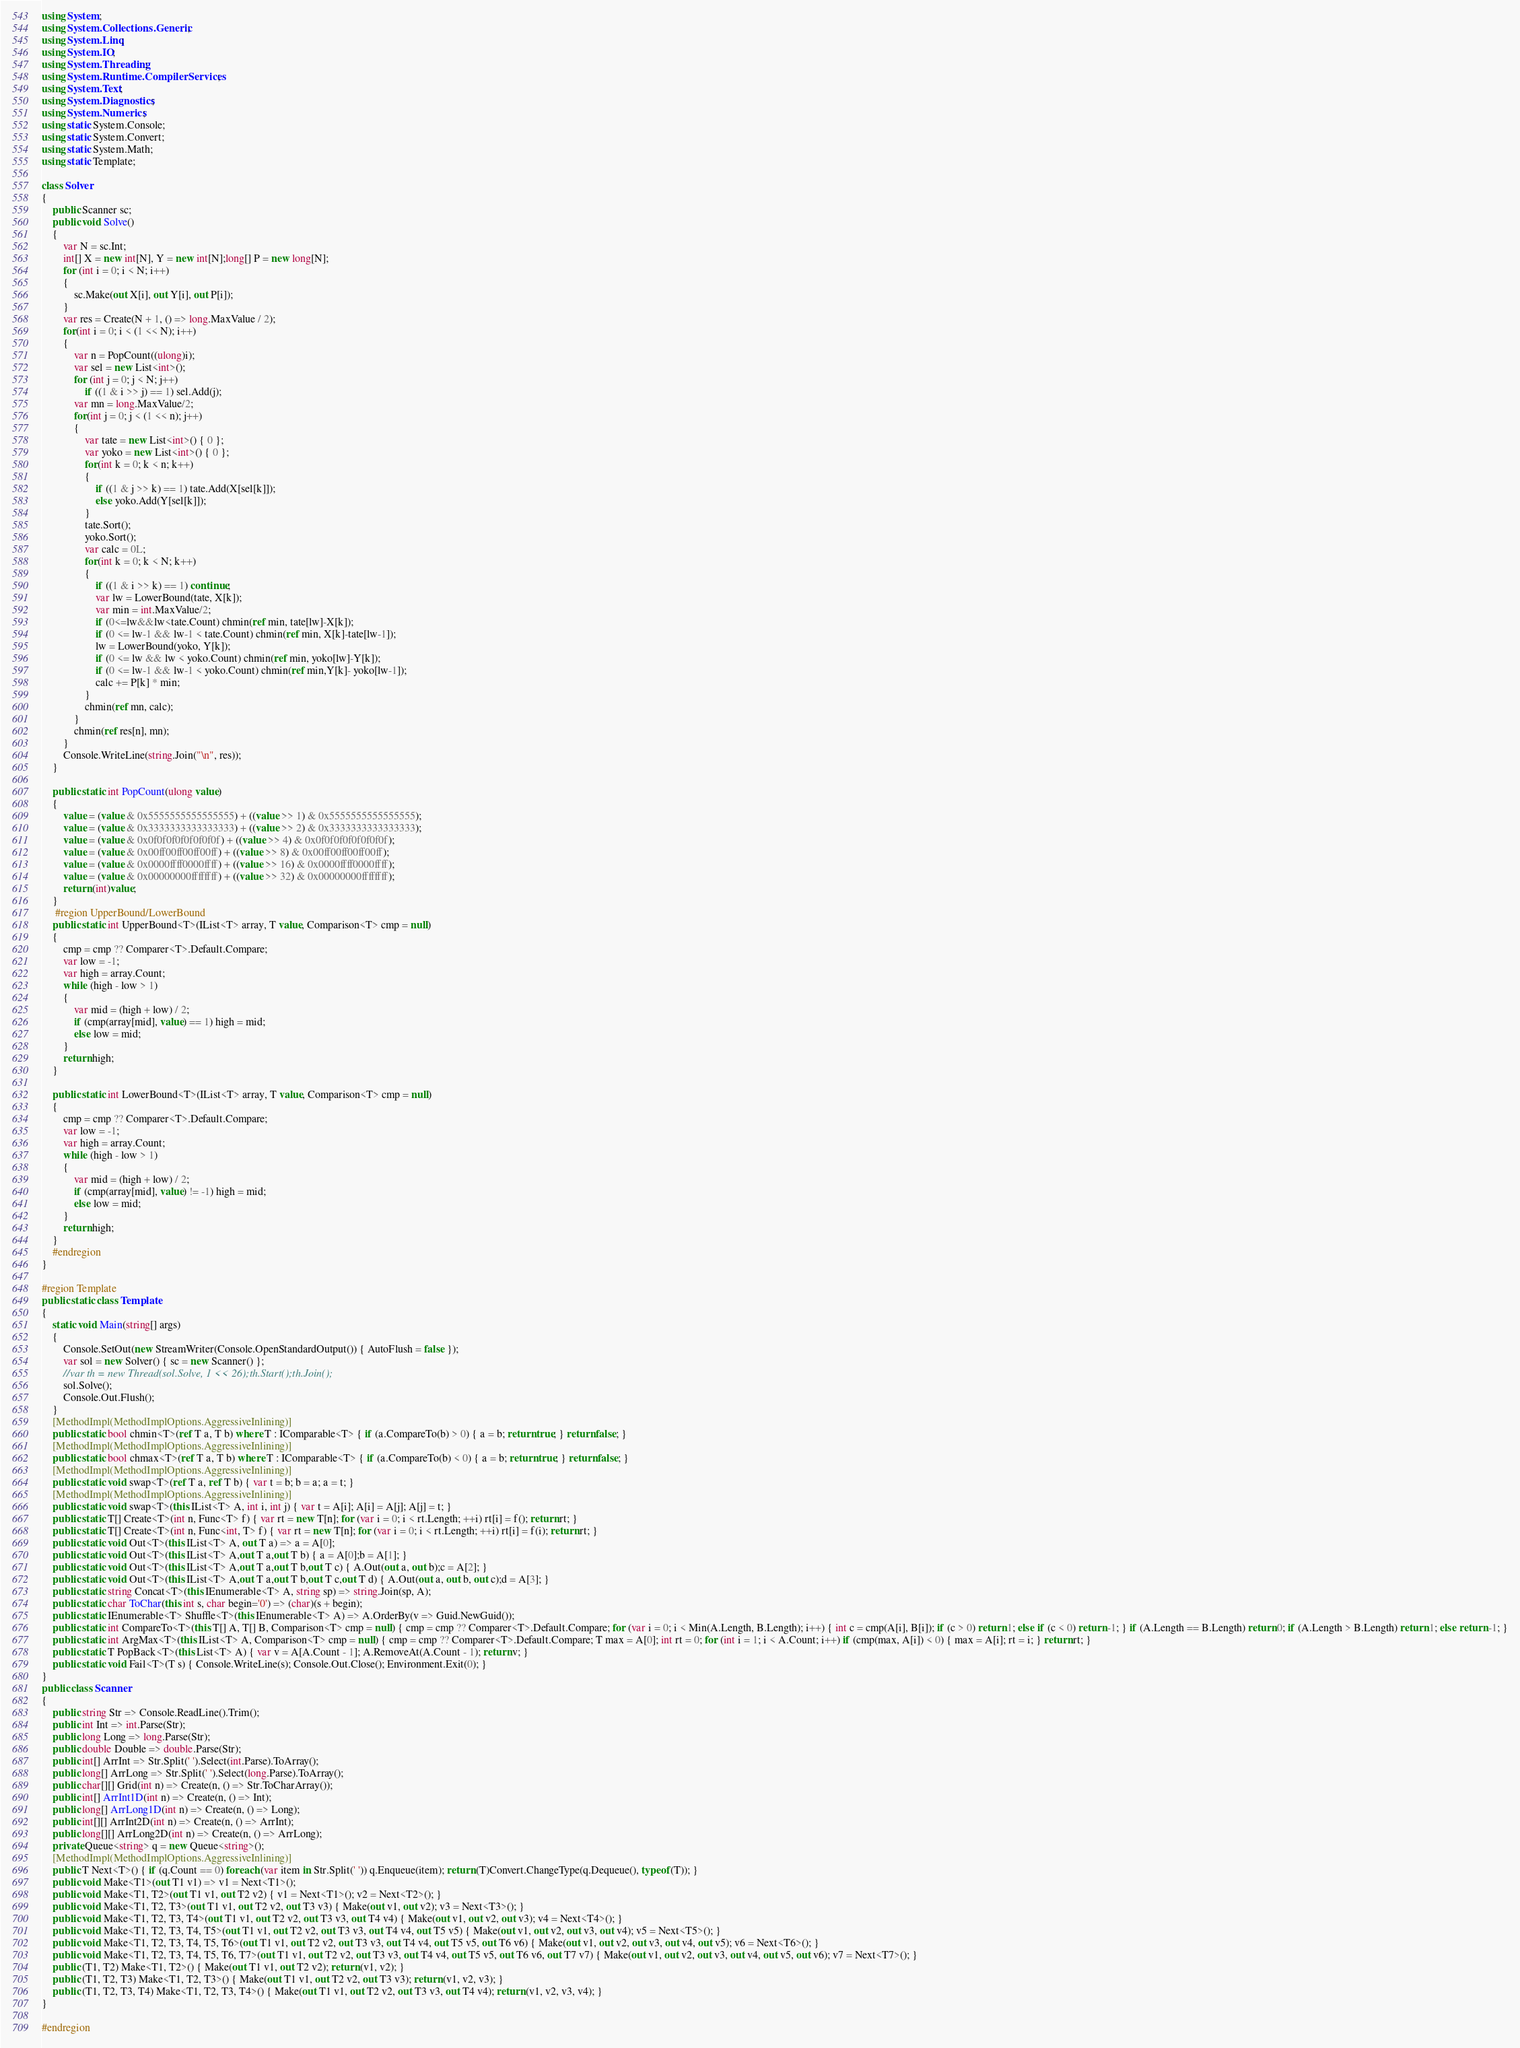<code> <loc_0><loc_0><loc_500><loc_500><_C#_>using System;
using System.Collections.Generic;
using System.Linq;
using System.IO;
using System.Threading;
using System.Runtime.CompilerServices;
using System.Text;
using System.Diagnostics;
using System.Numerics;
using static System.Console;
using static System.Convert;
using static System.Math;
using static Template;

class Solver
{
    public Scanner sc;
    public void Solve()
    {
        var N = sc.Int;
        int[] X = new int[N], Y = new int[N];long[] P = new long[N];
        for (int i = 0; i < N; i++)
        {
            sc.Make(out X[i], out Y[i], out P[i]);
        }
        var res = Create(N + 1, () => long.MaxValue / 2);
        for(int i = 0; i < (1 << N); i++)
        {
            var n = PopCount((ulong)i);
            var sel = new List<int>();
            for (int j = 0; j < N; j++)
                if ((1 & i >> j) == 1) sel.Add(j);
            var mn = long.MaxValue/2;
            for(int j = 0; j < (1 << n); j++)
            {
                var tate = new List<int>() { 0 };
                var yoko = new List<int>() { 0 };
                for(int k = 0; k < n; k++)
                {
                    if ((1 & j >> k) == 1) tate.Add(X[sel[k]]);
                    else yoko.Add(Y[sel[k]]);
                }
                tate.Sort();
                yoko.Sort();
                var calc = 0L;
                for(int k = 0; k < N; k++)
                {
                    if ((1 & i >> k) == 1) continue;
                    var lw = LowerBound(tate, X[k]);
                    var min = int.MaxValue/2;
                    if (0<=lw&&lw<tate.Count) chmin(ref min, tate[lw]-X[k]);
                    if (0 <= lw-1 && lw-1 < tate.Count) chmin(ref min, X[k]-tate[lw-1]);
                    lw = LowerBound(yoko, Y[k]);
                    if (0 <= lw && lw < yoko.Count) chmin(ref min, yoko[lw]-Y[k]);
                    if (0 <= lw-1 && lw-1 < yoko.Count) chmin(ref min,Y[k]- yoko[lw-1]);
                    calc += P[k] * min;
                }
                chmin(ref mn, calc);
            }
            chmin(ref res[n], mn);
        }
        Console.WriteLine(string.Join("\n", res));
    }

    public static int PopCount(ulong value)
    {
        value = (value & 0x5555555555555555) + ((value >> 1) & 0x5555555555555555);
        value = (value & 0x3333333333333333) + ((value >> 2) & 0x3333333333333333);
        value = (value & 0x0f0f0f0f0f0f0f0f) + ((value >> 4) & 0x0f0f0f0f0f0f0f0f);
        value = (value & 0x00ff00ff00ff00ff) + ((value >> 8) & 0x00ff00ff00ff00ff);
        value = (value & 0x0000ffff0000ffff) + ((value >> 16) & 0x0000ffff0000ffff);
        value = (value & 0x00000000ffffffff) + ((value >> 32) & 0x00000000ffffffff);
        return (int)value;
    }
     #region UpperBound/LowerBound
    public static int UpperBound<T>(IList<T> array, T value, Comparison<T> cmp = null)
    {
        cmp = cmp ?? Comparer<T>.Default.Compare;
        var low = -1;
        var high = array.Count;
        while (high - low > 1)
        {
            var mid = (high + low) / 2;
            if (cmp(array[mid], value) == 1) high = mid;
            else low = mid;
        }
        return high;
    }

    public static int LowerBound<T>(IList<T> array, T value, Comparison<T> cmp = null)
    {
        cmp = cmp ?? Comparer<T>.Default.Compare;
        var low = -1;
        var high = array.Count;
        while (high - low > 1)
        {
            var mid = (high + low) / 2;
            if (cmp(array[mid], value) != -1) high = mid;
            else low = mid;
        }
        return high;
    }
    #endregion
}

#region Template
public static class Template
{
    static void Main(string[] args)
    {
        Console.SetOut(new StreamWriter(Console.OpenStandardOutput()) { AutoFlush = false });
        var sol = new Solver() { sc = new Scanner() };
        //var th = new Thread(sol.Solve, 1 << 26);th.Start();th.Join();
        sol.Solve();
        Console.Out.Flush();
    }
    [MethodImpl(MethodImplOptions.AggressiveInlining)]
    public static bool chmin<T>(ref T a, T b) where T : IComparable<T> { if (a.CompareTo(b) > 0) { a = b; return true; } return false; }
    [MethodImpl(MethodImplOptions.AggressiveInlining)]
    public static bool chmax<T>(ref T a, T b) where T : IComparable<T> { if (a.CompareTo(b) < 0) { a = b; return true; } return false; }
    [MethodImpl(MethodImplOptions.AggressiveInlining)]
    public static void swap<T>(ref T a, ref T b) { var t = b; b = a; a = t; }
    [MethodImpl(MethodImplOptions.AggressiveInlining)]
    public static void swap<T>(this IList<T> A, int i, int j) { var t = A[i]; A[i] = A[j]; A[j] = t; }
    public static T[] Create<T>(int n, Func<T> f) { var rt = new T[n]; for (var i = 0; i < rt.Length; ++i) rt[i] = f(); return rt; }
    public static T[] Create<T>(int n, Func<int, T> f) { var rt = new T[n]; for (var i = 0; i < rt.Length; ++i) rt[i] = f(i); return rt; }
    public static void Out<T>(this IList<T> A, out T a) => a = A[0];
    public static void Out<T>(this IList<T> A,out T a,out T b) { a = A[0];b = A[1]; }
    public static void Out<T>(this IList<T> A,out T a,out T b,out T c) { A.Out(out a, out b);c = A[2]; }
    public static void Out<T>(this IList<T> A,out T a,out T b,out T c,out T d) { A.Out(out a, out b, out c);d = A[3]; }
    public static string Concat<T>(this IEnumerable<T> A, string sp) => string.Join(sp, A);
    public static char ToChar(this int s, char begin='0') => (char)(s + begin);
    public static IEnumerable<T> Shuffle<T>(this IEnumerable<T> A) => A.OrderBy(v => Guid.NewGuid());
    public static int CompareTo<T>(this T[] A, T[] B, Comparison<T> cmp = null) { cmp = cmp ?? Comparer<T>.Default.Compare; for (var i = 0; i < Min(A.Length, B.Length); i++) { int c = cmp(A[i], B[i]); if (c > 0) return 1; else if (c < 0) return -1; } if (A.Length == B.Length) return 0; if (A.Length > B.Length) return 1; else return -1; }
    public static int ArgMax<T>(this IList<T> A, Comparison<T> cmp = null) { cmp = cmp ?? Comparer<T>.Default.Compare; T max = A[0]; int rt = 0; for (int i = 1; i < A.Count; i++) if (cmp(max, A[i]) < 0) { max = A[i]; rt = i; } return rt; }
    public static T PopBack<T>(this List<T> A) { var v = A[A.Count - 1]; A.RemoveAt(A.Count - 1); return v; }
    public static void Fail<T>(T s) { Console.WriteLine(s); Console.Out.Close(); Environment.Exit(0); }
}
public class Scanner
{
    public string Str => Console.ReadLine().Trim();
    public int Int => int.Parse(Str);
    public long Long => long.Parse(Str);
    public double Double => double.Parse(Str);
    public int[] ArrInt => Str.Split(' ').Select(int.Parse).ToArray();
    public long[] ArrLong => Str.Split(' ').Select(long.Parse).ToArray();
    public char[][] Grid(int n) => Create(n, () => Str.ToCharArray());
    public int[] ArrInt1D(int n) => Create(n, () => Int);
    public long[] ArrLong1D(int n) => Create(n, () => Long);
    public int[][] ArrInt2D(int n) => Create(n, () => ArrInt);
    public long[][] ArrLong2D(int n) => Create(n, () => ArrLong);
    private Queue<string> q = new Queue<string>();
    [MethodImpl(MethodImplOptions.AggressiveInlining)]
    public T Next<T>() { if (q.Count == 0) foreach (var item in Str.Split(' ')) q.Enqueue(item); return (T)Convert.ChangeType(q.Dequeue(), typeof(T)); }
    public void Make<T1>(out T1 v1) => v1 = Next<T1>();
    public void Make<T1, T2>(out T1 v1, out T2 v2) { v1 = Next<T1>(); v2 = Next<T2>(); }
    public void Make<T1, T2, T3>(out T1 v1, out T2 v2, out T3 v3) { Make(out v1, out v2); v3 = Next<T3>(); }
    public void Make<T1, T2, T3, T4>(out T1 v1, out T2 v2, out T3 v3, out T4 v4) { Make(out v1, out v2, out v3); v4 = Next<T4>(); }
    public void Make<T1, T2, T3, T4, T5>(out T1 v1, out T2 v2, out T3 v3, out T4 v4, out T5 v5) { Make(out v1, out v2, out v3, out v4); v5 = Next<T5>(); }
    public void Make<T1, T2, T3, T4, T5, T6>(out T1 v1, out T2 v2, out T3 v3, out T4 v4, out T5 v5, out T6 v6) { Make(out v1, out v2, out v3, out v4, out v5); v6 = Next<T6>(); }
    public void Make<T1, T2, T3, T4, T5, T6, T7>(out T1 v1, out T2 v2, out T3 v3, out T4 v4, out T5 v5, out T6 v6, out T7 v7) { Make(out v1, out v2, out v3, out v4, out v5, out v6); v7 = Next<T7>(); }
    public (T1, T2) Make<T1, T2>() { Make(out T1 v1, out T2 v2); return (v1, v2); }
    public (T1, T2, T3) Make<T1, T2, T3>() { Make(out T1 v1, out T2 v2, out T3 v3); return (v1, v2, v3); }
    public (T1, T2, T3, T4) Make<T1, T2, T3, T4>() { Make(out T1 v1, out T2 v2, out T3 v3, out T4 v4); return (v1, v2, v3, v4); }
}

#endregion</code> 